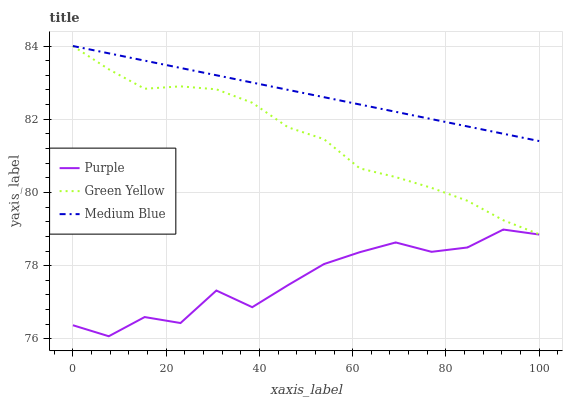Does Green Yellow have the minimum area under the curve?
Answer yes or no. No. Does Green Yellow have the maximum area under the curve?
Answer yes or no. No. Is Green Yellow the smoothest?
Answer yes or no. No. Is Green Yellow the roughest?
Answer yes or no. No. Does Green Yellow have the lowest value?
Answer yes or no. No. Is Purple less than Green Yellow?
Answer yes or no. Yes. Is Medium Blue greater than Purple?
Answer yes or no. Yes. Does Purple intersect Green Yellow?
Answer yes or no. No. 